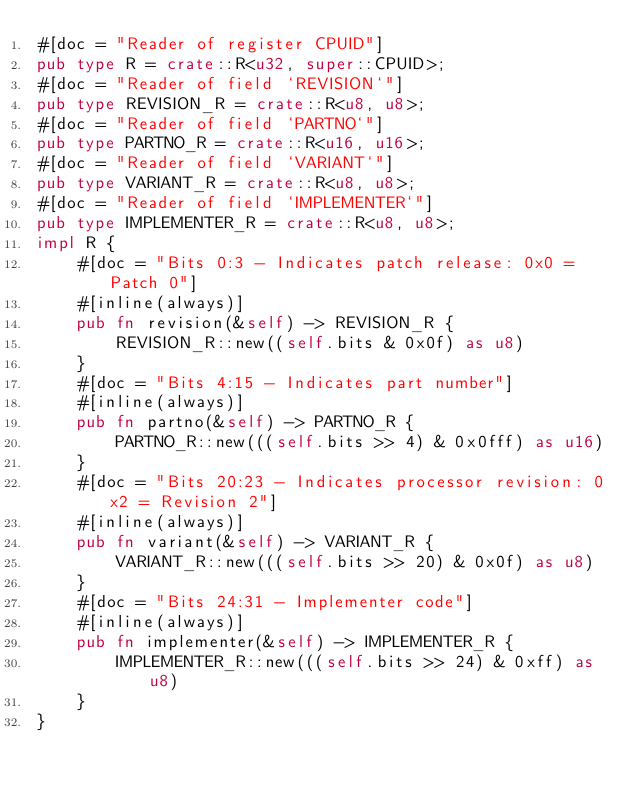Convert code to text. <code><loc_0><loc_0><loc_500><loc_500><_Rust_>#[doc = "Reader of register CPUID"]
pub type R = crate::R<u32, super::CPUID>;
#[doc = "Reader of field `REVISION`"]
pub type REVISION_R = crate::R<u8, u8>;
#[doc = "Reader of field `PARTNO`"]
pub type PARTNO_R = crate::R<u16, u16>;
#[doc = "Reader of field `VARIANT`"]
pub type VARIANT_R = crate::R<u8, u8>;
#[doc = "Reader of field `IMPLEMENTER`"]
pub type IMPLEMENTER_R = crate::R<u8, u8>;
impl R {
    #[doc = "Bits 0:3 - Indicates patch release: 0x0 = Patch 0"]
    #[inline(always)]
    pub fn revision(&self) -> REVISION_R {
        REVISION_R::new((self.bits & 0x0f) as u8)
    }
    #[doc = "Bits 4:15 - Indicates part number"]
    #[inline(always)]
    pub fn partno(&self) -> PARTNO_R {
        PARTNO_R::new(((self.bits >> 4) & 0x0fff) as u16)
    }
    #[doc = "Bits 20:23 - Indicates processor revision: 0x2 = Revision 2"]
    #[inline(always)]
    pub fn variant(&self) -> VARIANT_R {
        VARIANT_R::new(((self.bits >> 20) & 0x0f) as u8)
    }
    #[doc = "Bits 24:31 - Implementer code"]
    #[inline(always)]
    pub fn implementer(&self) -> IMPLEMENTER_R {
        IMPLEMENTER_R::new(((self.bits >> 24) & 0xff) as u8)
    }
}
</code> 